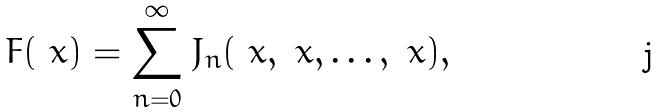<formula> <loc_0><loc_0><loc_500><loc_500>F ( \ x ) = \sum _ { n = 0 } ^ { \infty } J _ { n } ( \ x , \ x , \dots , \ x ) ,</formula> 